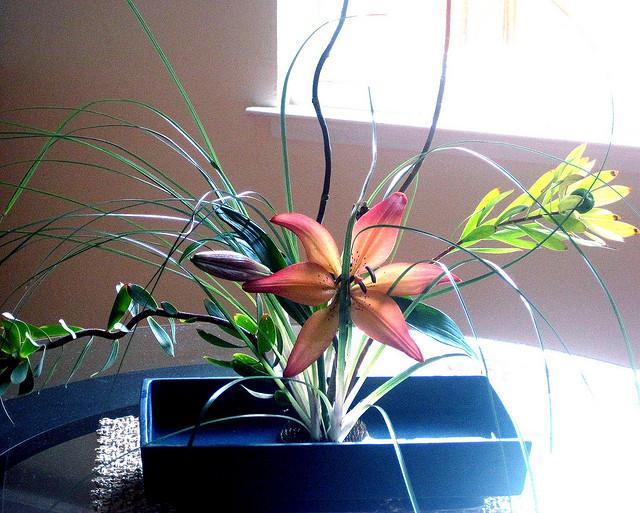Are these real flowers?
Be succinct. Yes. What kind of flower is this?
Write a very short answer. Lily. How many flowers are in this scene?
Quick response, please. 1. 